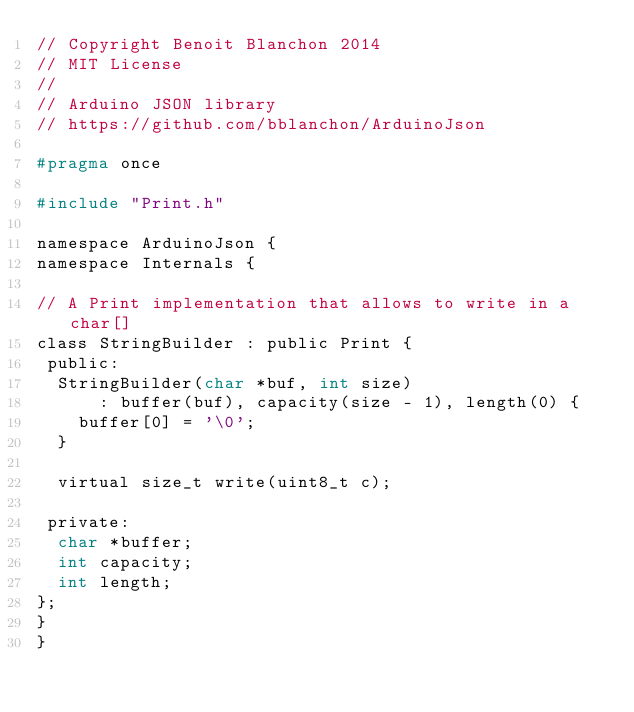<code> <loc_0><loc_0><loc_500><loc_500><_C_>// Copyright Benoit Blanchon 2014
// MIT License
//
// Arduino JSON library
// https://github.com/bblanchon/ArduinoJson

#pragma once

#include "Print.h"

namespace ArduinoJson {
namespace Internals {

// A Print implementation that allows to write in a char[]
class StringBuilder : public Print {
 public:
  StringBuilder(char *buf, int size)
      : buffer(buf), capacity(size - 1), length(0) {
    buffer[0] = '\0';
  }

  virtual size_t write(uint8_t c);

 private:
  char *buffer;
  int capacity;
  int length;
};
}
}
</code> 